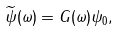<formula> <loc_0><loc_0><loc_500><loc_500>\widetilde { \psi } ( \omega ) = G ( \omega ) \psi _ { 0 } ,</formula> 